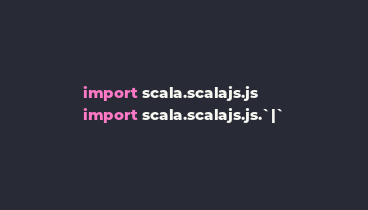Convert code to text. <code><loc_0><loc_0><loc_500><loc_500><_Scala_>import scala.scalajs.js
import scala.scalajs.js.`|`</code> 